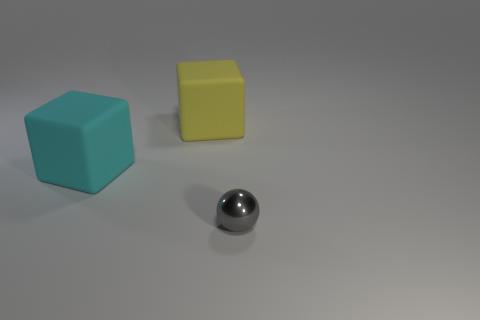Is the number of rubber things that are on the right side of the cyan matte cube less than the number of things behind the gray metallic object?
Offer a very short reply. Yes. How many things are either tiny yellow balls or rubber cubes on the right side of the large cyan cube?
Your answer should be very brief. 1. There is a cube that is the same size as the yellow thing; what is it made of?
Your answer should be very brief. Rubber. Does the yellow thing have the same material as the cyan thing?
Your response must be concise. Yes. The object that is both in front of the yellow thing and behind the gray metal sphere is what color?
Ensure brevity in your answer.  Cyan. There is another rubber thing that is the same size as the cyan rubber thing; what shape is it?
Offer a very short reply. Cube. What number of other objects are the same color as the small metallic thing?
Provide a short and direct response. 0. How many other objects are the same material as the big yellow cube?
Your answer should be compact. 1. There is a cyan cube; does it have the same size as the rubber block on the right side of the large cyan rubber thing?
Offer a terse response. Yes. What color is the small shiny ball?
Provide a short and direct response. Gray. 